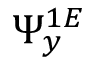<formula> <loc_0><loc_0><loc_500><loc_500>\Psi _ { y } ^ { 1 E }</formula> 